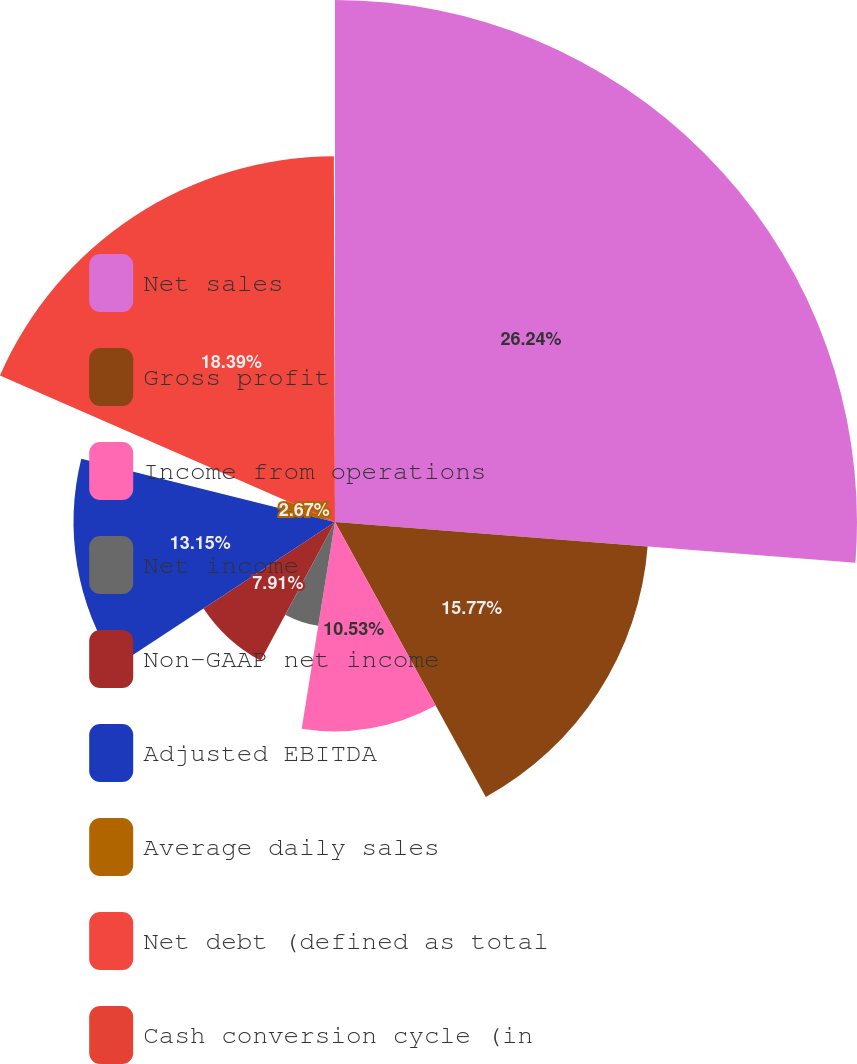Convert chart to OTSL. <chart><loc_0><loc_0><loc_500><loc_500><pie_chart><fcel>Net sales<fcel>Gross profit<fcel>Income from operations<fcel>Net income<fcel>Non-GAAP net income<fcel>Adjusted EBITDA<fcel>Average daily sales<fcel>Net debt (defined as total<fcel>Cash conversion cycle (in<nl><fcel>26.25%<fcel>15.77%<fcel>10.53%<fcel>5.29%<fcel>7.91%<fcel>13.15%<fcel>2.67%<fcel>18.39%<fcel>0.05%<nl></chart> 